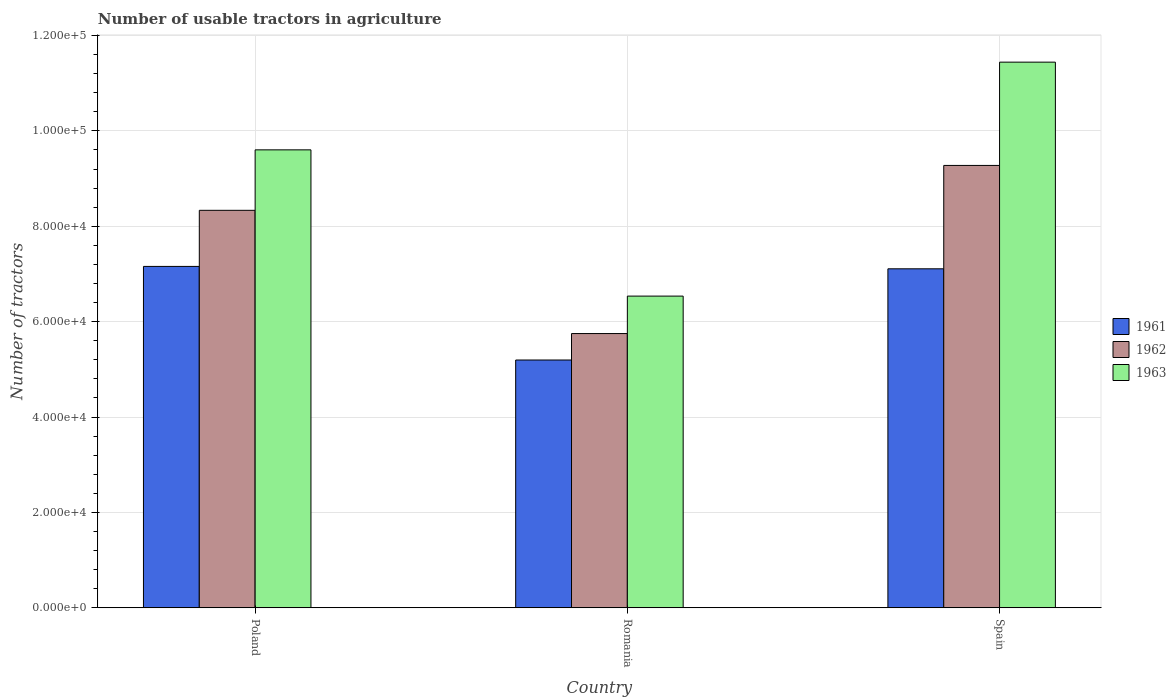How many different coloured bars are there?
Give a very brief answer. 3. How many groups of bars are there?
Your answer should be compact. 3. Are the number of bars on each tick of the X-axis equal?
Give a very brief answer. Yes. In how many cases, is the number of bars for a given country not equal to the number of legend labels?
Ensure brevity in your answer.  0. What is the number of usable tractors in agriculture in 1963 in Romania?
Your answer should be compact. 6.54e+04. Across all countries, what is the maximum number of usable tractors in agriculture in 1963?
Keep it short and to the point. 1.14e+05. Across all countries, what is the minimum number of usable tractors in agriculture in 1963?
Keep it short and to the point. 6.54e+04. In which country was the number of usable tractors in agriculture in 1961 maximum?
Provide a short and direct response. Poland. In which country was the number of usable tractors in agriculture in 1963 minimum?
Offer a very short reply. Romania. What is the total number of usable tractors in agriculture in 1962 in the graph?
Ensure brevity in your answer.  2.34e+05. What is the difference between the number of usable tractors in agriculture in 1963 in Poland and that in Romania?
Ensure brevity in your answer.  3.07e+04. What is the difference between the number of usable tractors in agriculture in 1963 in Spain and the number of usable tractors in agriculture in 1961 in Poland?
Keep it short and to the point. 4.28e+04. What is the average number of usable tractors in agriculture in 1961 per country?
Your response must be concise. 6.49e+04. What is the difference between the number of usable tractors in agriculture of/in 1962 and number of usable tractors in agriculture of/in 1963 in Poland?
Your response must be concise. -1.27e+04. What is the ratio of the number of usable tractors in agriculture in 1962 in Poland to that in Spain?
Keep it short and to the point. 0.9. Is the number of usable tractors in agriculture in 1961 in Poland less than that in Spain?
Provide a short and direct response. No. Is the difference between the number of usable tractors in agriculture in 1962 in Poland and Spain greater than the difference between the number of usable tractors in agriculture in 1963 in Poland and Spain?
Your response must be concise. Yes. What is the difference between the highest and the second highest number of usable tractors in agriculture in 1961?
Your response must be concise. -1.96e+04. What is the difference between the highest and the lowest number of usable tractors in agriculture in 1963?
Keep it short and to the point. 4.91e+04. What does the 2nd bar from the left in Poland represents?
Provide a short and direct response. 1962. Are all the bars in the graph horizontal?
Your response must be concise. No. What is the difference between two consecutive major ticks on the Y-axis?
Offer a very short reply. 2.00e+04. Are the values on the major ticks of Y-axis written in scientific E-notation?
Ensure brevity in your answer.  Yes. Does the graph contain grids?
Provide a succinct answer. Yes. Where does the legend appear in the graph?
Ensure brevity in your answer.  Center right. How are the legend labels stacked?
Keep it short and to the point. Vertical. What is the title of the graph?
Make the answer very short. Number of usable tractors in agriculture. What is the label or title of the Y-axis?
Make the answer very short. Number of tractors. What is the Number of tractors in 1961 in Poland?
Your answer should be very brief. 7.16e+04. What is the Number of tractors of 1962 in Poland?
Offer a terse response. 8.33e+04. What is the Number of tractors of 1963 in Poland?
Provide a succinct answer. 9.60e+04. What is the Number of tractors of 1961 in Romania?
Offer a terse response. 5.20e+04. What is the Number of tractors in 1962 in Romania?
Offer a terse response. 5.75e+04. What is the Number of tractors in 1963 in Romania?
Your answer should be very brief. 6.54e+04. What is the Number of tractors in 1961 in Spain?
Your answer should be compact. 7.11e+04. What is the Number of tractors of 1962 in Spain?
Provide a short and direct response. 9.28e+04. What is the Number of tractors in 1963 in Spain?
Make the answer very short. 1.14e+05. Across all countries, what is the maximum Number of tractors in 1961?
Your answer should be very brief. 7.16e+04. Across all countries, what is the maximum Number of tractors in 1962?
Provide a short and direct response. 9.28e+04. Across all countries, what is the maximum Number of tractors of 1963?
Provide a short and direct response. 1.14e+05. Across all countries, what is the minimum Number of tractors of 1961?
Your response must be concise. 5.20e+04. Across all countries, what is the minimum Number of tractors of 1962?
Your answer should be compact. 5.75e+04. Across all countries, what is the minimum Number of tractors in 1963?
Give a very brief answer. 6.54e+04. What is the total Number of tractors in 1961 in the graph?
Offer a very short reply. 1.95e+05. What is the total Number of tractors of 1962 in the graph?
Provide a short and direct response. 2.34e+05. What is the total Number of tractors in 1963 in the graph?
Offer a very short reply. 2.76e+05. What is the difference between the Number of tractors of 1961 in Poland and that in Romania?
Your response must be concise. 1.96e+04. What is the difference between the Number of tractors of 1962 in Poland and that in Romania?
Your answer should be very brief. 2.58e+04. What is the difference between the Number of tractors of 1963 in Poland and that in Romania?
Your answer should be very brief. 3.07e+04. What is the difference between the Number of tractors in 1962 in Poland and that in Spain?
Give a very brief answer. -9414. What is the difference between the Number of tractors of 1963 in Poland and that in Spain?
Offer a very short reply. -1.84e+04. What is the difference between the Number of tractors in 1961 in Romania and that in Spain?
Your answer should be compact. -1.91e+04. What is the difference between the Number of tractors in 1962 in Romania and that in Spain?
Provide a succinct answer. -3.53e+04. What is the difference between the Number of tractors of 1963 in Romania and that in Spain?
Your response must be concise. -4.91e+04. What is the difference between the Number of tractors of 1961 in Poland and the Number of tractors of 1962 in Romania?
Make the answer very short. 1.41e+04. What is the difference between the Number of tractors of 1961 in Poland and the Number of tractors of 1963 in Romania?
Your response must be concise. 6226. What is the difference between the Number of tractors in 1962 in Poland and the Number of tractors in 1963 in Romania?
Ensure brevity in your answer.  1.80e+04. What is the difference between the Number of tractors of 1961 in Poland and the Number of tractors of 1962 in Spain?
Offer a terse response. -2.12e+04. What is the difference between the Number of tractors in 1961 in Poland and the Number of tractors in 1963 in Spain?
Your answer should be very brief. -4.28e+04. What is the difference between the Number of tractors in 1962 in Poland and the Number of tractors in 1963 in Spain?
Provide a short and direct response. -3.11e+04. What is the difference between the Number of tractors in 1961 in Romania and the Number of tractors in 1962 in Spain?
Your answer should be compact. -4.08e+04. What is the difference between the Number of tractors in 1961 in Romania and the Number of tractors in 1963 in Spain?
Give a very brief answer. -6.25e+04. What is the difference between the Number of tractors in 1962 in Romania and the Number of tractors in 1963 in Spain?
Give a very brief answer. -5.69e+04. What is the average Number of tractors in 1961 per country?
Offer a terse response. 6.49e+04. What is the average Number of tractors of 1962 per country?
Give a very brief answer. 7.79e+04. What is the average Number of tractors of 1963 per country?
Your response must be concise. 9.19e+04. What is the difference between the Number of tractors of 1961 and Number of tractors of 1962 in Poland?
Your answer should be very brief. -1.18e+04. What is the difference between the Number of tractors in 1961 and Number of tractors in 1963 in Poland?
Provide a short and direct response. -2.44e+04. What is the difference between the Number of tractors in 1962 and Number of tractors in 1963 in Poland?
Your answer should be compact. -1.27e+04. What is the difference between the Number of tractors of 1961 and Number of tractors of 1962 in Romania?
Keep it short and to the point. -5548. What is the difference between the Number of tractors of 1961 and Number of tractors of 1963 in Romania?
Provide a short and direct response. -1.34e+04. What is the difference between the Number of tractors of 1962 and Number of tractors of 1963 in Romania?
Your answer should be very brief. -7851. What is the difference between the Number of tractors in 1961 and Number of tractors in 1962 in Spain?
Offer a very short reply. -2.17e+04. What is the difference between the Number of tractors of 1961 and Number of tractors of 1963 in Spain?
Provide a succinct answer. -4.33e+04. What is the difference between the Number of tractors in 1962 and Number of tractors in 1963 in Spain?
Offer a terse response. -2.17e+04. What is the ratio of the Number of tractors in 1961 in Poland to that in Romania?
Your response must be concise. 1.38. What is the ratio of the Number of tractors in 1962 in Poland to that in Romania?
Ensure brevity in your answer.  1.45. What is the ratio of the Number of tractors in 1963 in Poland to that in Romania?
Ensure brevity in your answer.  1.47. What is the ratio of the Number of tractors in 1961 in Poland to that in Spain?
Your answer should be very brief. 1.01. What is the ratio of the Number of tractors of 1962 in Poland to that in Spain?
Your answer should be very brief. 0.9. What is the ratio of the Number of tractors of 1963 in Poland to that in Spain?
Your answer should be very brief. 0.84. What is the ratio of the Number of tractors in 1961 in Romania to that in Spain?
Your answer should be very brief. 0.73. What is the ratio of the Number of tractors in 1962 in Romania to that in Spain?
Offer a terse response. 0.62. What is the ratio of the Number of tractors in 1963 in Romania to that in Spain?
Give a very brief answer. 0.57. What is the difference between the highest and the second highest Number of tractors in 1962?
Keep it short and to the point. 9414. What is the difference between the highest and the second highest Number of tractors of 1963?
Provide a short and direct response. 1.84e+04. What is the difference between the highest and the lowest Number of tractors in 1961?
Keep it short and to the point. 1.96e+04. What is the difference between the highest and the lowest Number of tractors in 1962?
Make the answer very short. 3.53e+04. What is the difference between the highest and the lowest Number of tractors in 1963?
Your answer should be very brief. 4.91e+04. 